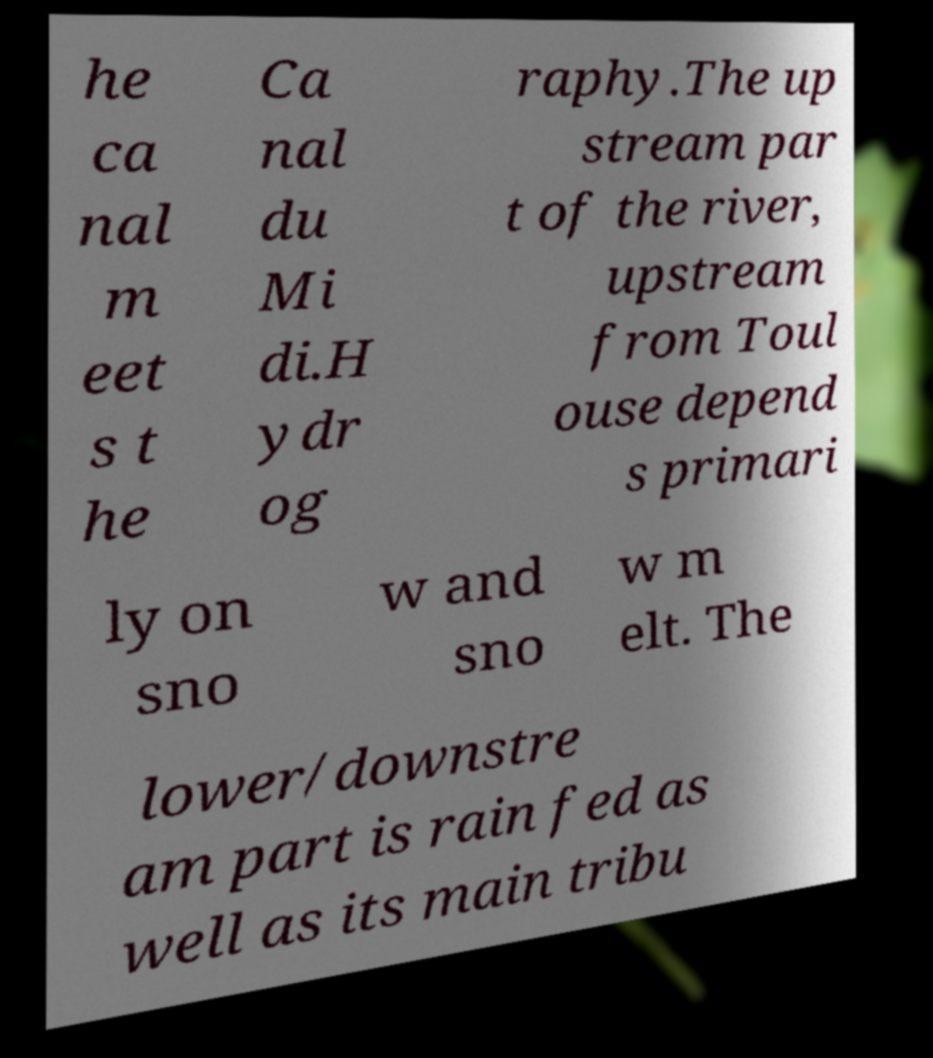Please identify and transcribe the text found in this image. he ca nal m eet s t he Ca nal du Mi di.H ydr og raphy.The up stream par t of the river, upstream from Toul ouse depend s primari ly on sno w and sno w m elt. The lower/downstre am part is rain fed as well as its main tribu 